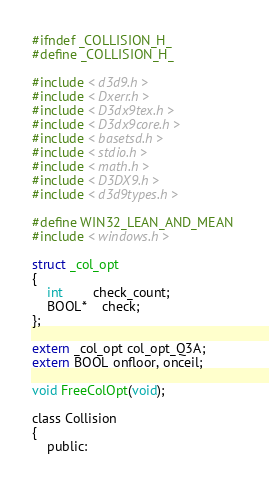<code> <loc_0><loc_0><loc_500><loc_500><_C_>

#ifndef _COLLISION_H_
#define _COLLISION_H_

#include < d3d9.h >
#include < Dxerr.h >
#include < D3dx9tex.h >
#include < D3dx9core.h >
#include < basetsd.h >
#include < stdio.h >
#include < math.h >
#include < D3DX9.h >
#include < d3d9types.h >

#define WIN32_LEAN_AND_MEAN 
#include < windows.h >

struct _col_opt
{
	int		check_count;
	BOOL*	check;
};

extern _col_opt col_opt_Q3A;
extern BOOL onfloor, onceil;

void FreeColOpt(void);

class Collision 
{
	public:</code> 